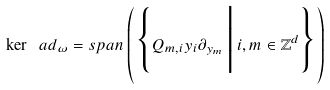Convert formula to latex. <formula><loc_0><loc_0><loc_500><loc_500>\ker \ a d _ { \omega } = s p a n \left ( \Big \{ Q _ { m , i } y _ { i } \partial _ { y _ { m } } \, \Big | \, i , m \in \mathbb { Z } ^ { d } \Big \} \right )</formula> 